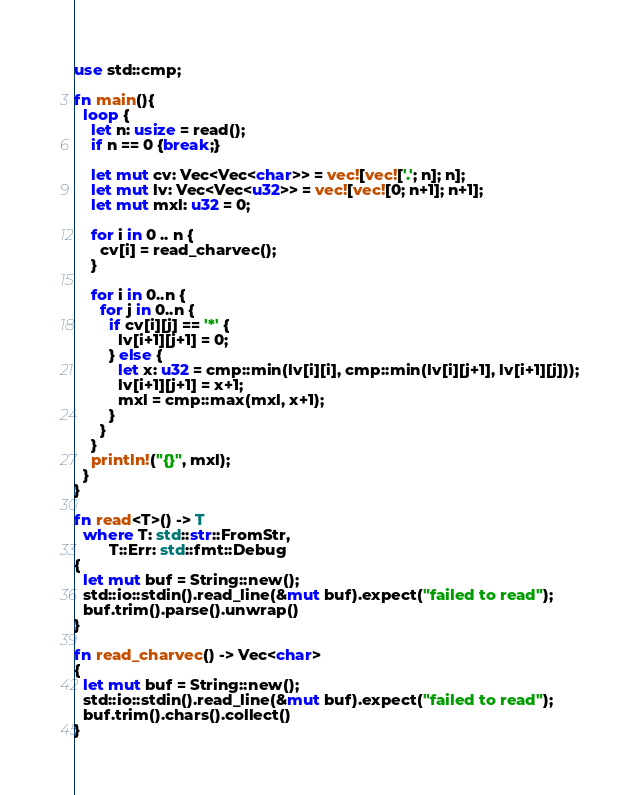Convert code to text. <code><loc_0><loc_0><loc_500><loc_500><_Rust_>use std::cmp;

fn main(){
  loop {
    let n: usize = read();
    if n == 0 {break;}
    
    let mut cv: Vec<Vec<char>> = vec![vec!['.'; n]; n];
    let mut lv: Vec<Vec<u32>> = vec![vec![0; n+1]; n+1];
    let mut mxl: u32 = 0;
    
    for i in 0 .. n {
      cv[i] = read_charvec();
    }
  
    for i in 0..n {
      for j in 0..n {
        if cv[i][j] == '*' {
          lv[i+1][j+1] = 0;
        } else {
          let x: u32 = cmp::min(lv[i][i], cmp::min(lv[i][j+1], lv[i+1][j]));
          lv[i+1][j+1] = x+1;
          mxl = cmp::max(mxl, x+1);
        }
      }
    }
    println!("{}", mxl);
  }
}

fn read<T>() -> T
  where T: std::str::FromStr,
        T::Err: std::fmt::Debug
{
  let mut buf = String::new();
  std::io::stdin().read_line(&mut buf).expect("failed to read");
  buf.trim().parse().unwrap()
}

fn read_charvec() -> Vec<char>
{
  let mut buf = String::new();
  std::io::stdin().read_line(&mut buf).expect("failed to read");
  buf.trim().chars().collect()
}

</code> 